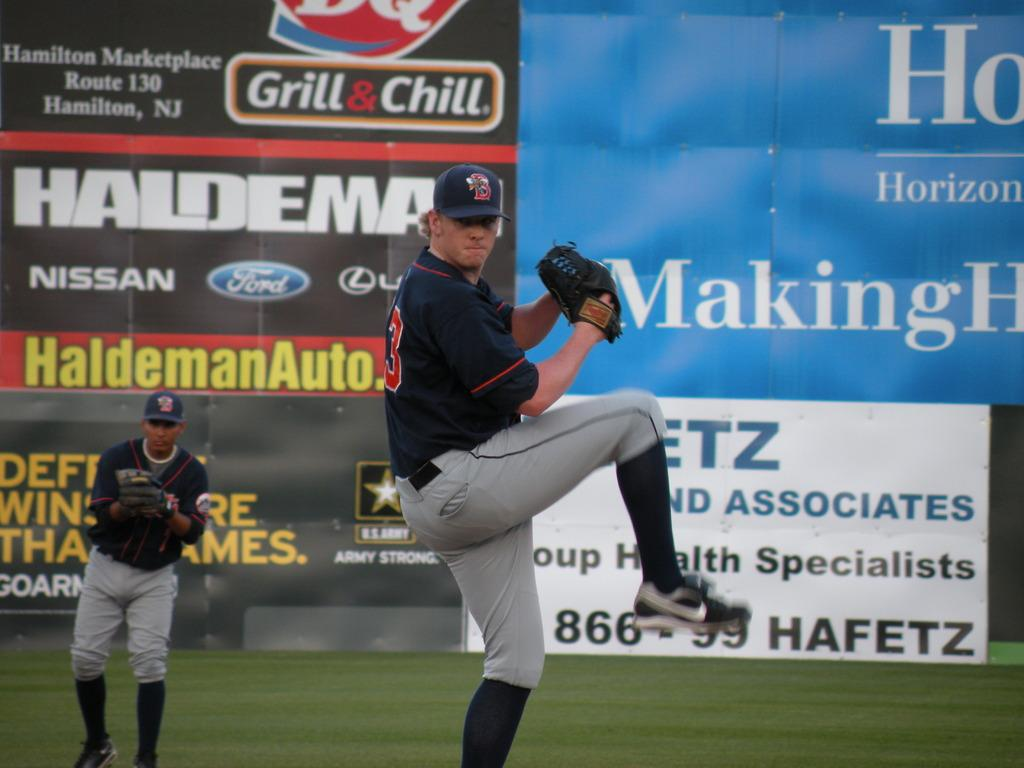<image>
Write a terse but informative summary of the picture. A baseball pitcher with the number three on his back is getting ready to throw a ball. 